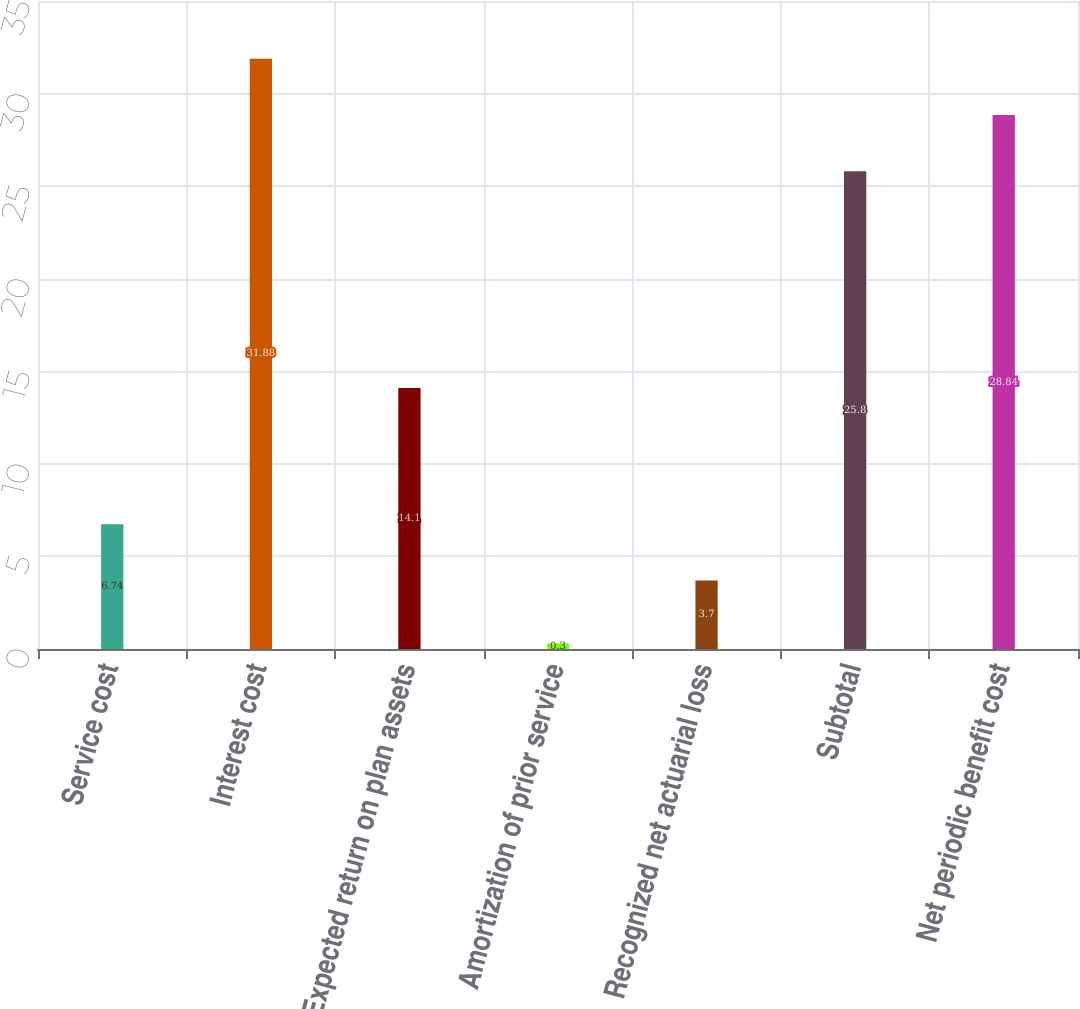Convert chart. <chart><loc_0><loc_0><loc_500><loc_500><bar_chart><fcel>Service cost<fcel>Interest cost<fcel>Expected return on plan assets<fcel>Amortization of prior service<fcel>Recognized net actuarial loss<fcel>Subtotal<fcel>Net periodic benefit cost<nl><fcel>6.74<fcel>31.88<fcel>14.1<fcel>0.3<fcel>3.7<fcel>25.8<fcel>28.84<nl></chart> 